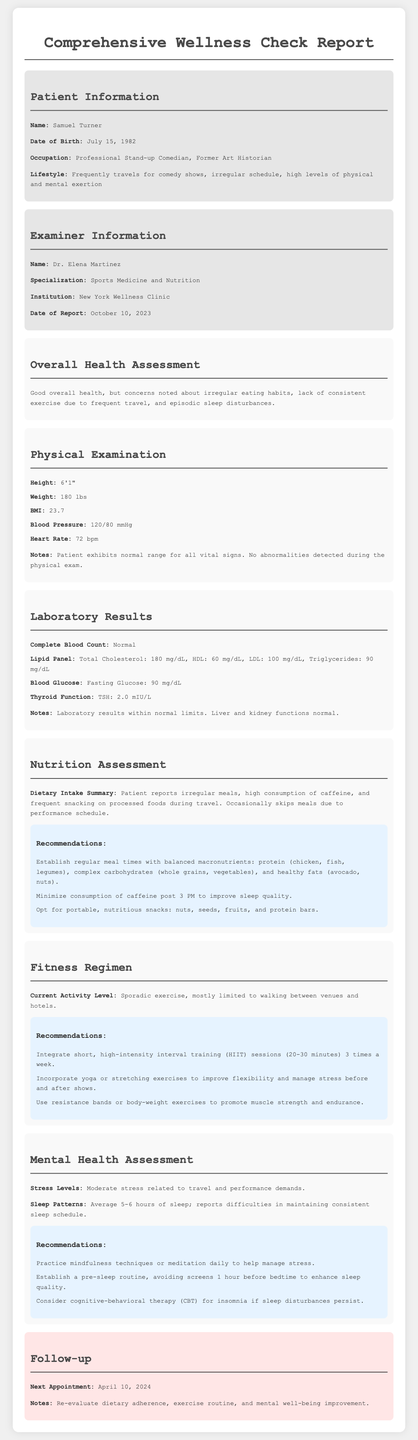What is the patient's name? The patient's name is listed in the patient information section.
Answer: Samuel Turner What is the date of the report? The date of the report is mentioned in the examiner information section.
Answer: October 10, 2023 What is the patient's BMI? The BMI is provided in the physical examination details.
Answer: 23.7 What are the recommended portable snacks? Portable snacks are listed in the nutrition assessment recommendations.
Answer: Nuts, seeds, fruits, and protein bars How many hours of sleep does the patient average? The average sleep hours are noted in the mental health assessment.
Answer: 5-6 hours What is the patient's occupation? The occupation is specified in the patient information section.
Answer: Professional Stand-up Comedian, Former Art Historian What is Dr. Elena Martinez's specialization? The specialization is mentioned in the examiner information section.
Answer: Sports Medicine and Nutrition How often should high-intensity interval training be integrated? The frequency of HIIT sessions is outlined in the fitness regimen recommendations.
Answer: 3 times a week What is the next appointment date? The next appointment date is indicated in the follow-up section.
Answer: April 10, 2024 